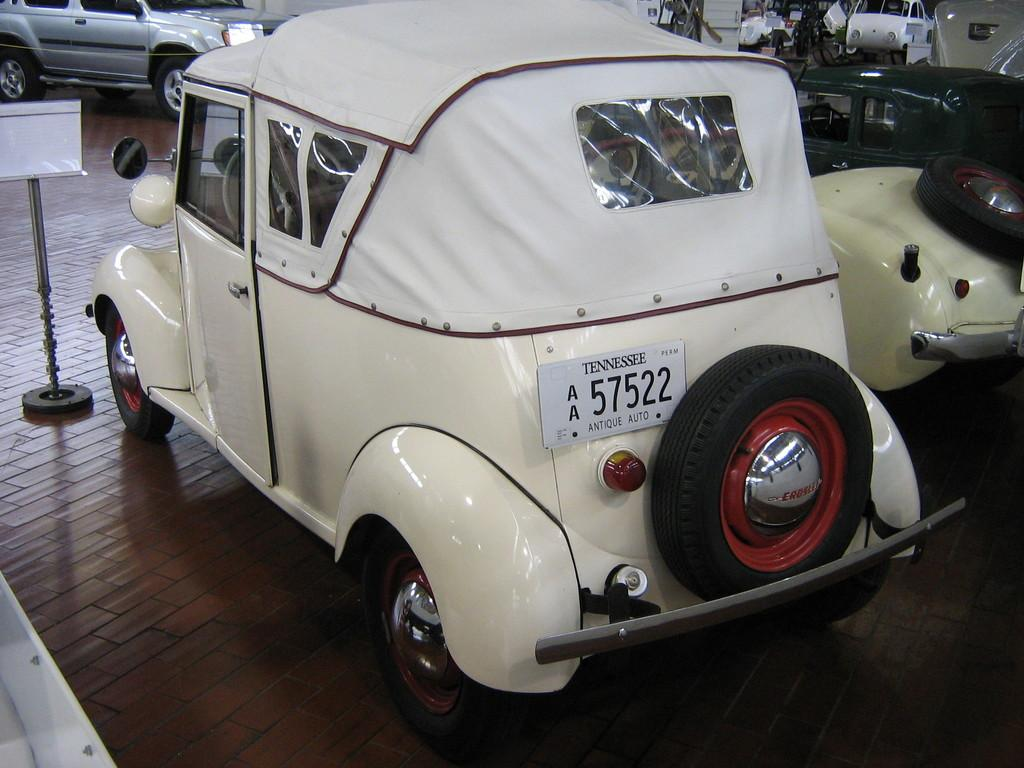What type of vehicles are in the image? There are vintage cars in the image. Are there any other types of vehicles besides the vintage cars? Yes, there are other vehicles in the image. Where are the vehicles located? The vehicles are parked on a wooden floor. What color is the notebook on the hood of the vintage car? There is no notebook present on the hood of the vintage car in the image. 